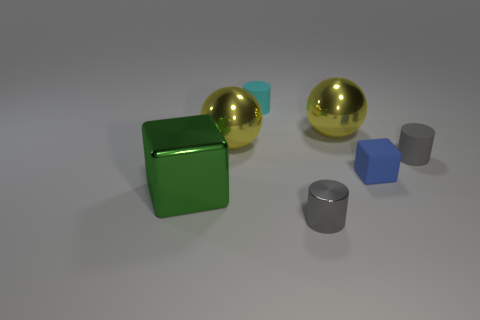Add 3 yellow spheres. How many objects exist? 10 Subtract all spheres. How many objects are left? 5 Add 7 tiny yellow matte spheres. How many tiny yellow matte spheres exist? 7 Subtract 0 blue spheres. How many objects are left? 7 Subtract all small gray metallic cylinders. Subtract all spheres. How many objects are left? 4 Add 5 small gray metallic cylinders. How many small gray metallic cylinders are left? 6 